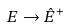Convert formula to latex. <formula><loc_0><loc_0><loc_500><loc_500>E \rightarrow \hat { E } ^ { + }</formula> 